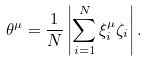Convert formula to latex. <formula><loc_0><loc_0><loc_500><loc_500>\theta ^ { \mu } = \frac { 1 } { N } \left | \sum _ { i = 1 } ^ { N } { \xi ^ { \mu } _ { i } \zeta _ { i } } \right | .</formula> 